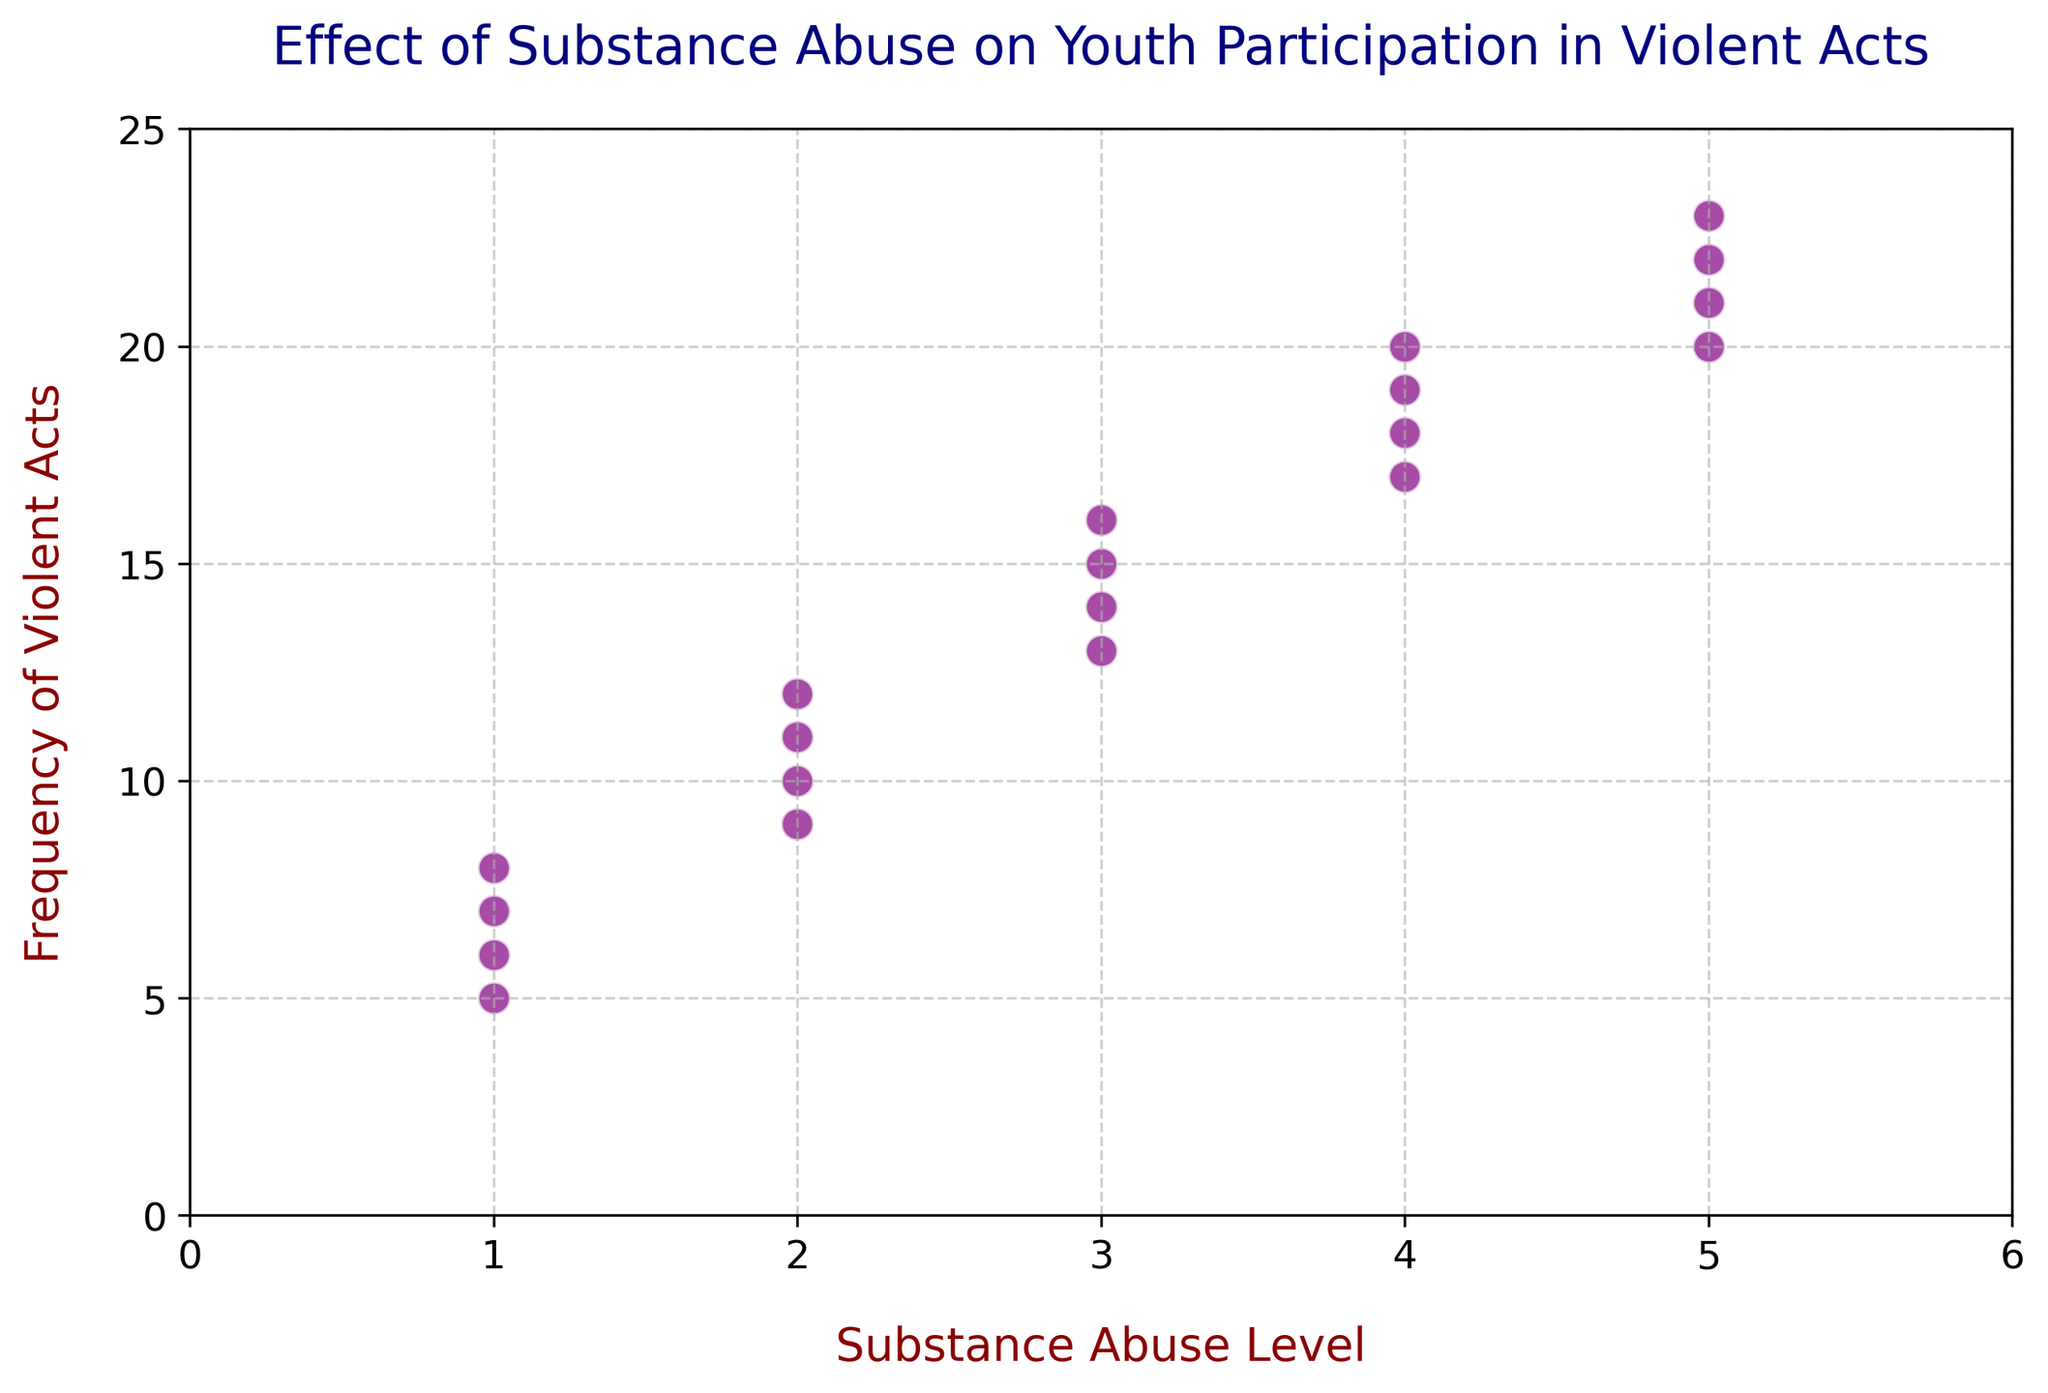What's the highest level of substance abuse recorded in the figure? The highest level of substance abuse can be determined by identifying the maximum value on the x-axis representing the Substance Abuse Level. Here, it is 5.
Answer: 5 Is there a trend between substance abuse level and the frequency of violent acts? Observing the scatter plot, as the Substance Abuse Level increases, the Frequency of Violent Acts also increases. This indicates a positive correlation.
Answer: Yes, there's a positive trend What is the frequency of violent acts when the substance abuse level is 3? By locating the points where the Substance Abuse Level is 3 on the x-axis, the corresponding y-axis values show frequencies of 15, 13, 14, and 16.
Answer: 15, 13, 14, and 16 Which substance abuse level has the lowest recorded frequency of violent acts? By comparing the y-values for each Substance Abuse Level, the minimum y-value is 5, which corresponds to the Substance Abuse Level of 1.
Answer: 1 How many instances have a substance abuse level of 4? Counting the points where the x-axis value is 4, there are four instances.
Answer: 4 What is the average frequency of violent acts for a substance abuse level of 2? Sum the frequencies corresponding to a Substance Abuse Level of 2 (10, 9, 11, 12), then divide by the number of points. (10 + 9 + 11 + 12) / 4 = 42 / 4 = 10.5
Answer: 10.5 Compare the frequency of violent acts between the highest and lowest substance abuse levels. The highest substance abuse level (5) has frequencies 20, 21, 22, 23. The lowest level (1) has frequencies 7, 6, 8, 5. Comparing maximum values, 23 (for level 5) is greater than 8 (for level 1).
Answer: Higher for level 5 Which data points have an equal frequency of violent acts? Identify points with the same y-value. Points with frequencies of 20 and 17 have equal values.
Answer: None Are there any outliers in the data? Observing the scatter plot, there are no data points that appear significantly distant from others, indicating no outliers.
Answer: No What's the most frequent substance abuse level in the dataset? By counting occurrences of each substance abuse level, we see that levels 2, 3, and 4 each appear 4 times, making them the most frequent.
Answer: 2, 3, and 4 